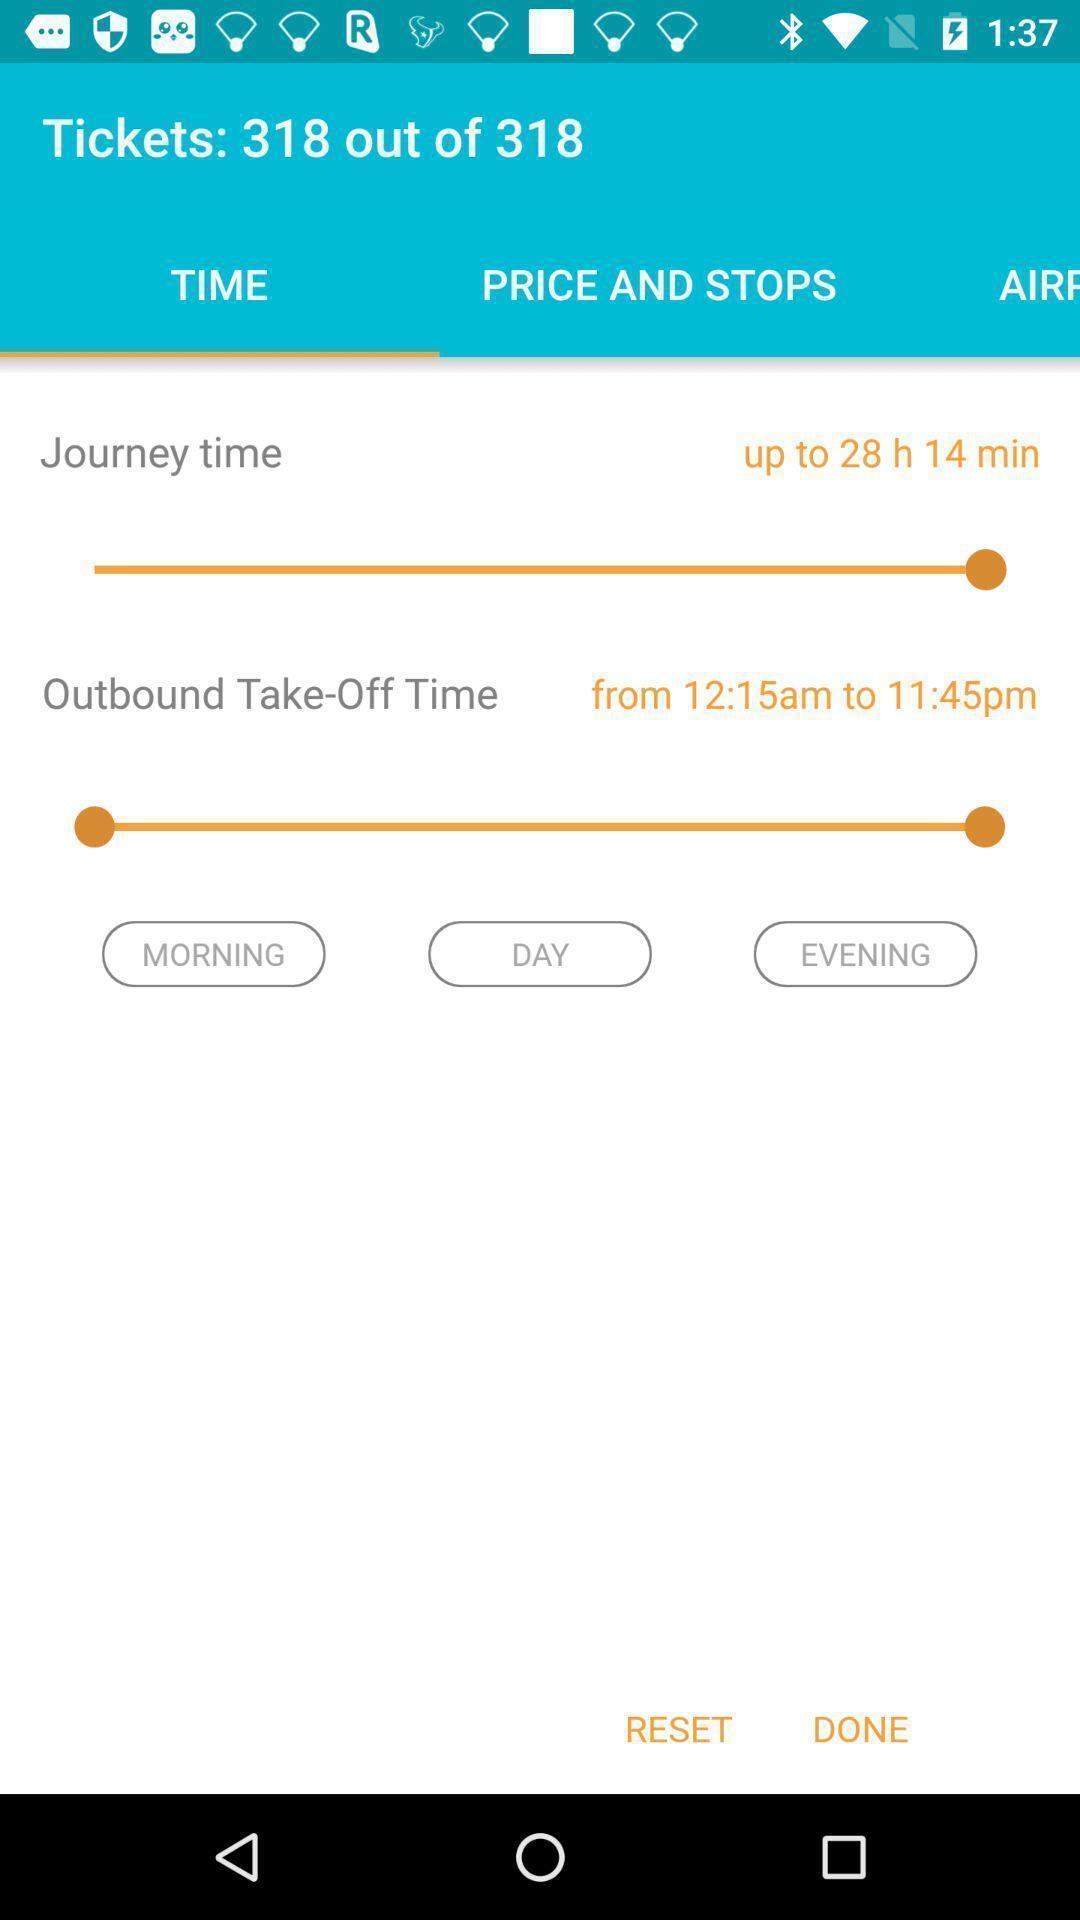Please provide a description for this image. Screen showing journey time and take off time. 